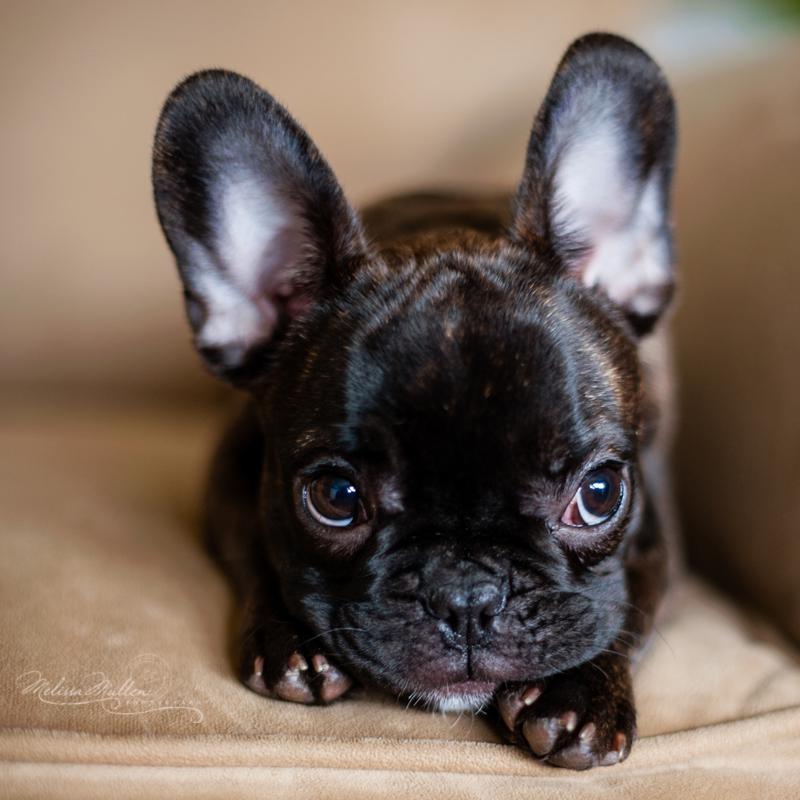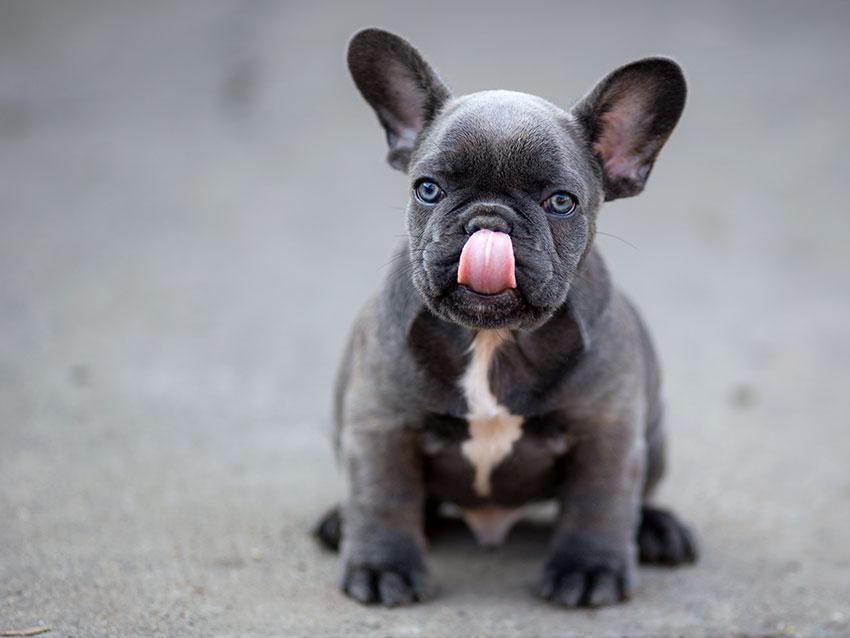The first image is the image on the left, the second image is the image on the right. Given the left and right images, does the statement "The left image features a dark big-eared puppy reclining on its belly with both paws forward and visible, with its body turned forward and its eyes glancing sideways." hold true? Answer yes or no. Yes. The first image is the image on the left, the second image is the image on the right. For the images displayed, is the sentence "The dog in the image on the left is lying down." factually correct? Answer yes or no. Yes. 